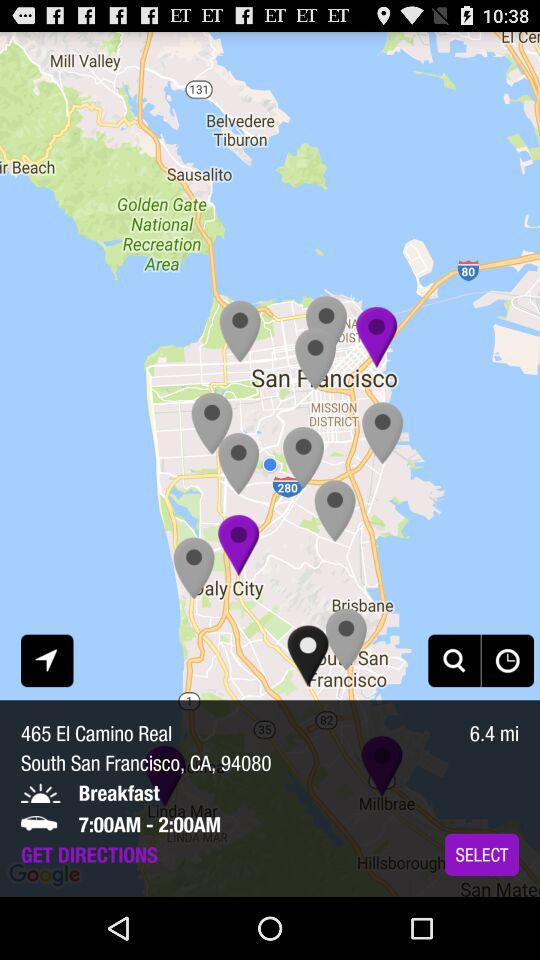What is the distance between the user and the restaurant?
Answer the question using a single word or phrase. 6.4 mi 